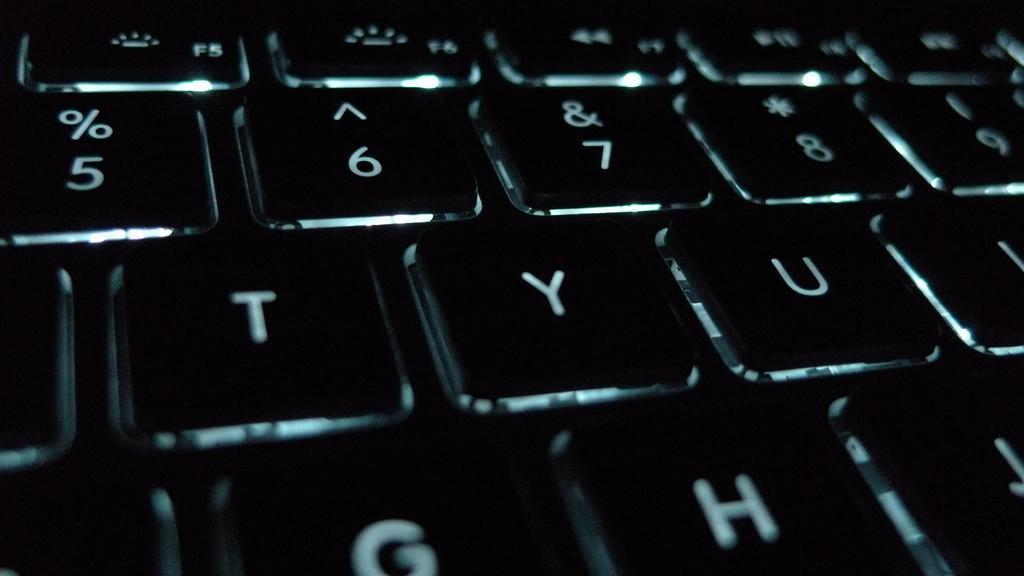Provide a one-sentence caption for the provided image. A closeup of a keyboard with the letters TYU. 